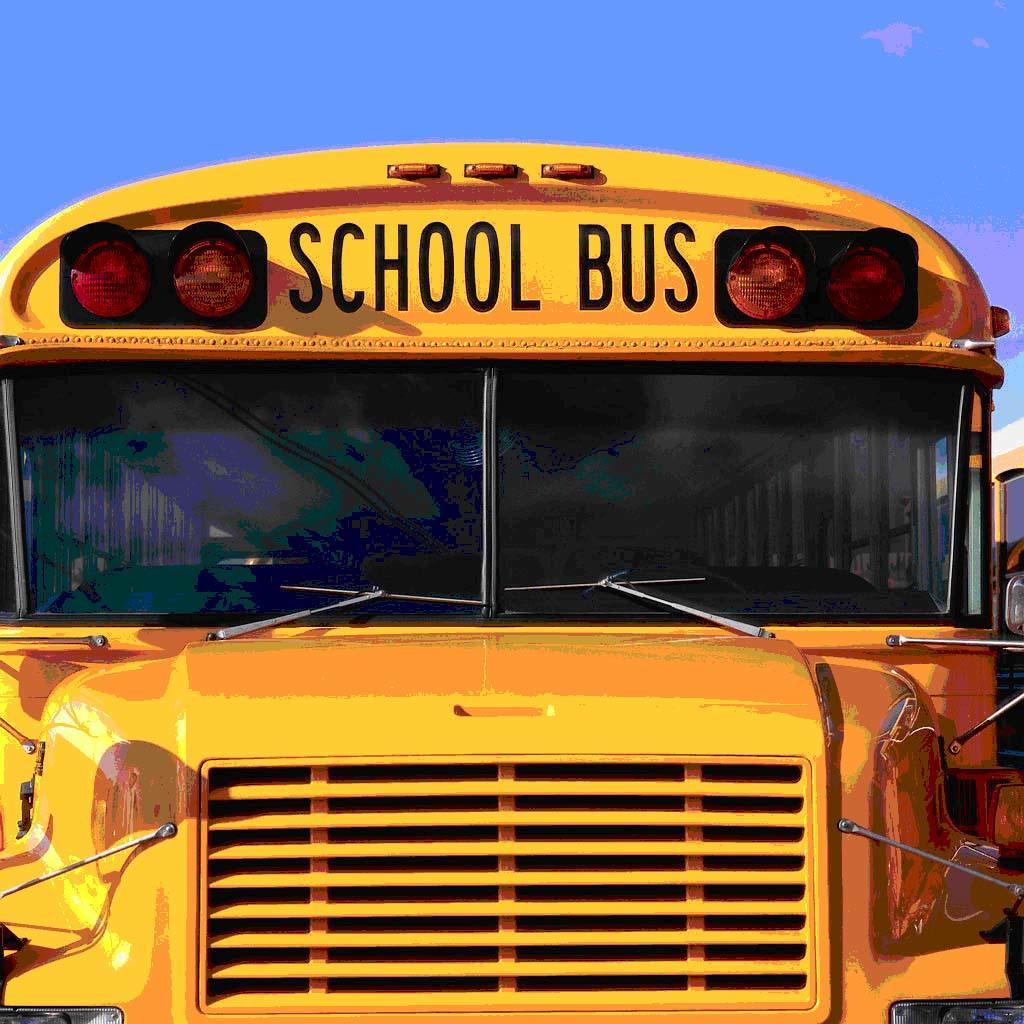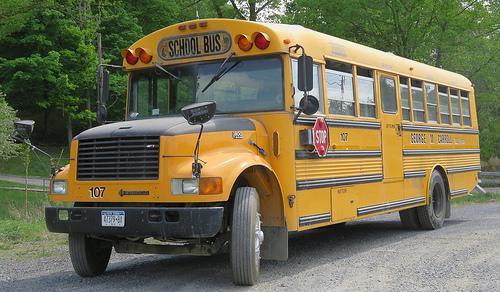The first image is the image on the left, the second image is the image on the right. Evaluate the accuracy of this statement regarding the images: "In at least one image there is a single view of a flat front end bus with its windshield wiper up.". Is it true? Answer yes or no. No. The first image is the image on the left, the second image is the image on the right. Given the left and right images, does the statement "At least one of the images shows a bus from the right side and its stop sign is visible." hold true? Answer yes or no. Yes. 